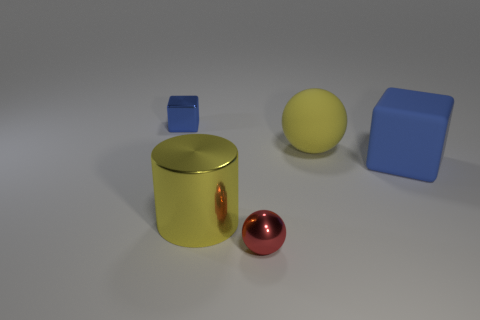Subtract all red balls. How many balls are left? 1 Add 1 brown metallic cylinders. How many brown metallic cylinders exist? 1 Add 4 small blue objects. How many objects exist? 9 Subtract 0 gray cylinders. How many objects are left? 5 Subtract all cubes. How many objects are left? 3 Subtract 1 blocks. How many blocks are left? 1 Subtract all brown cubes. Subtract all gray cylinders. How many cubes are left? 2 Subtract all brown cubes. How many yellow balls are left? 1 Subtract all small red matte cylinders. Subtract all big blocks. How many objects are left? 4 Add 5 blue rubber cubes. How many blue rubber cubes are left? 6 